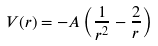Convert formula to latex. <formula><loc_0><loc_0><loc_500><loc_500>V ( r ) = - A \left ( \frac { 1 } { r ^ { 2 } } - \frac { 2 } { r } \right )</formula> 